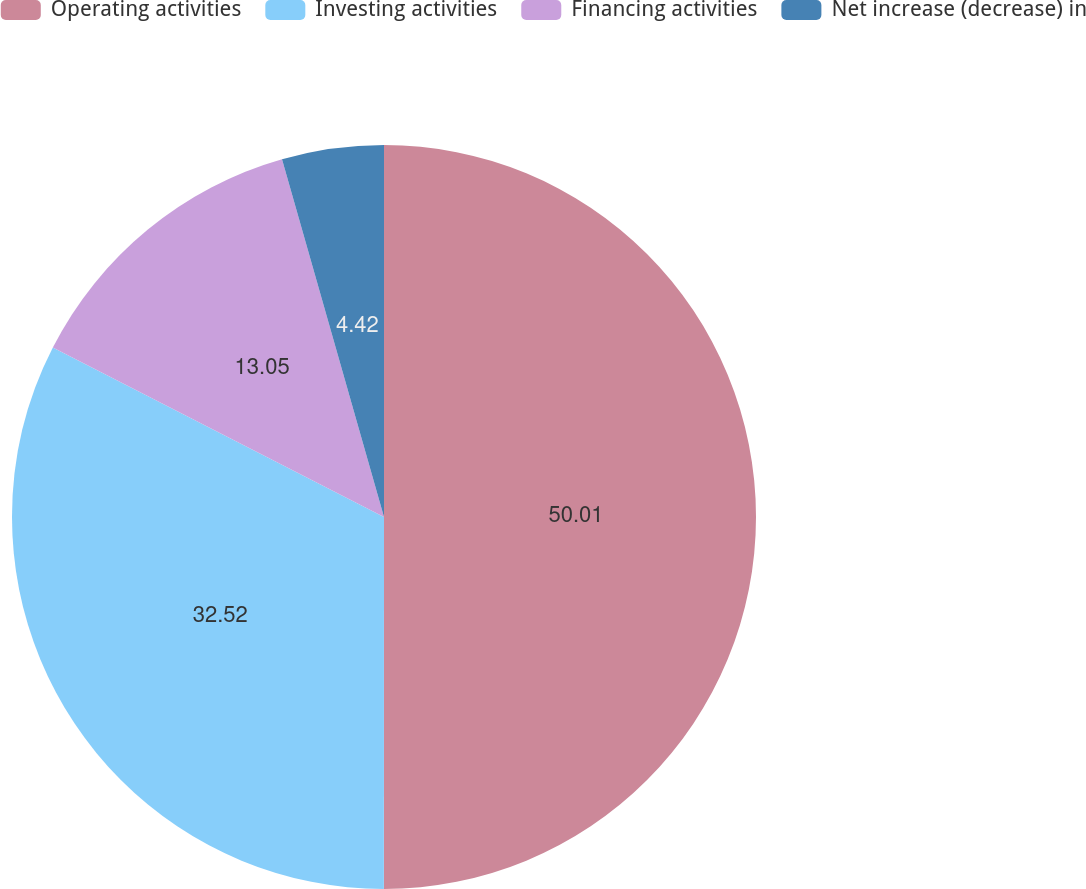<chart> <loc_0><loc_0><loc_500><loc_500><pie_chart><fcel>Operating activities<fcel>Investing activities<fcel>Financing activities<fcel>Net increase (decrease) in<nl><fcel>50.0%<fcel>32.52%<fcel>13.05%<fcel>4.42%<nl></chart> 